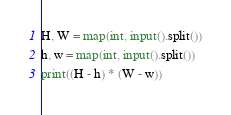<code> <loc_0><loc_0><loc_500><loc_500><_Python_>H, W = map(int, input().split())
h, w = map(int, input().split())
print((H - h) * (W - w))
</code> 